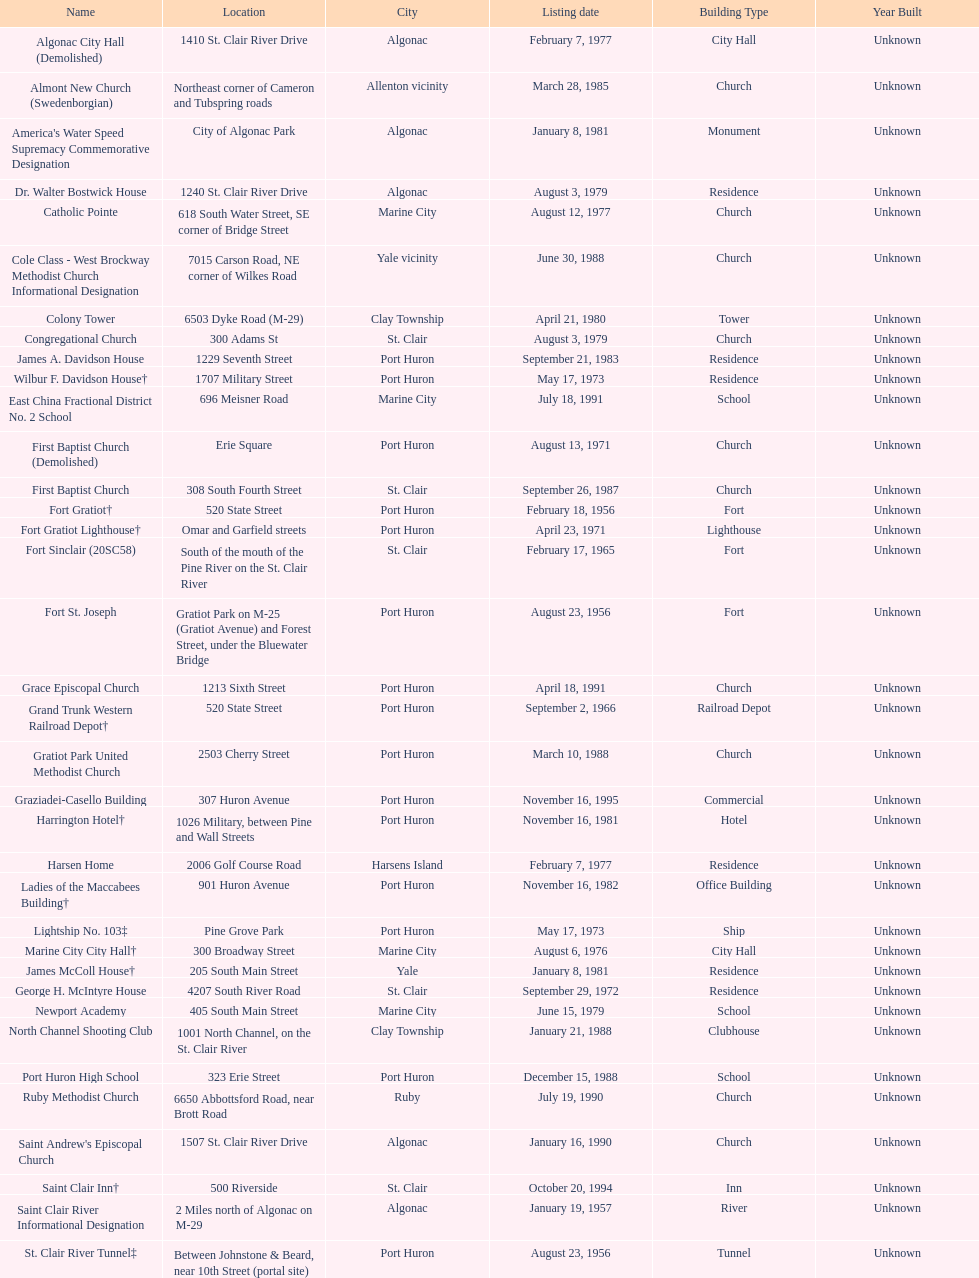Which city is home to the greatest number of historic sites, existing or demolished? Port Huron. 